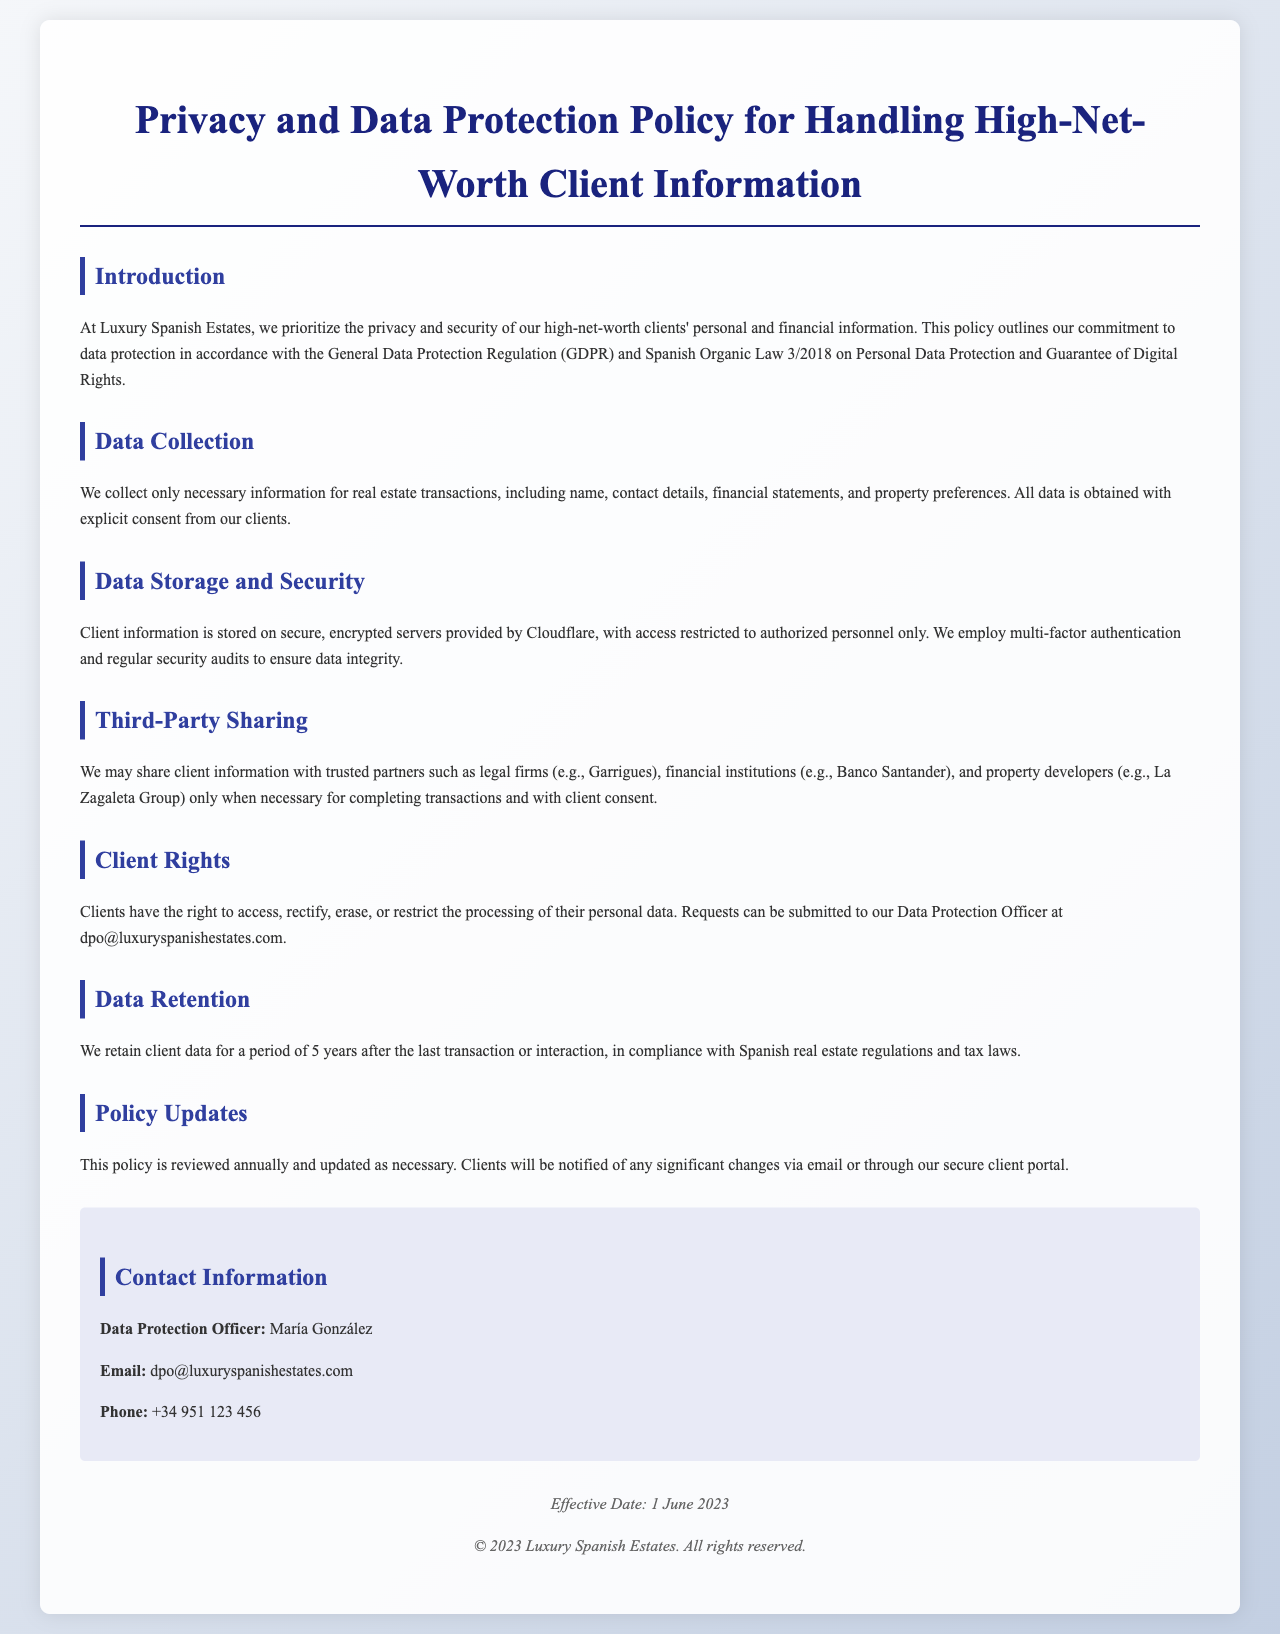What legislation does the policy follow? The document mentions that the policy is in accordance with GDPR and Spanish Organic Law 3/2018.
Answer: GDPR and Spanish Organic Law 3/2018 What type of information is collected from clients? The document states that necessary information for real estate transactions, including name, contact details, financial statements, and property preferences, is collected.
Answer: Name, contact details, financial statements, property preferences How long is client data retained according to the policy? The policy specifies that client data is retained for a period of 5 years after the last transaction or interaction.
Answer: 5 years Who is the Data Protection Officer? The document provides the name of the Data Protection Officer in the contact information section.
Answer: María González What measures are taken for data storage security? The document states that client information is stored on secure, encrypted servers with restricted access.
Answer: Secure, encrypted servers What is the effective date of this policy? The effective date is clearly mentioned in the footer of the document.
Answer: 1 June 2023 What rights do clients have regarding their personal data? The document outlines that clients can access, rectify, erase, or restrict processing of their personal data.
Answer: Access, rectify, erase, restrict processing Which financial institution is mentioned in relation to third-party sharing? The policy mentions a specific financial institution as a trusted partner for sharing client information.
Answer: Banco Santander 